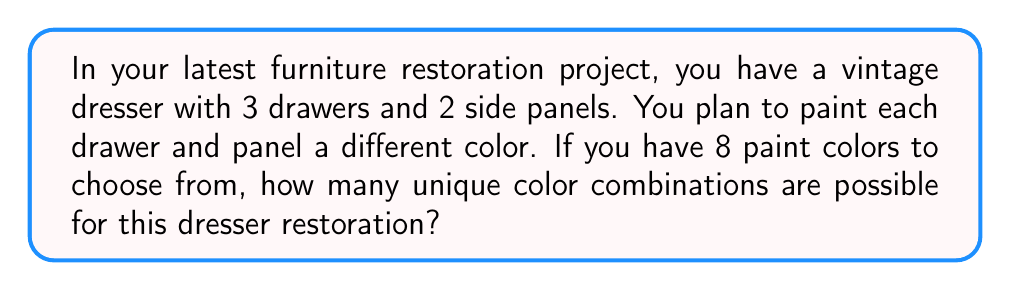Show me your answer to this math problem. Let's approach this step-by-step:

1) We need to choose colors for 5 different parts of the dresser (3 drawers and 2 side panels).

2) For each part, we have 8 color choices.

3) We're selecting colors without replacement, as each part needs to be a different color.

4) This scenario is a perfect application of the permutation formula.

5) The permutation formula is:

   $$P(n,r) = \frac{n!}{(n-r)!}$$

   Where $n$ is the total number of options (in this case, 8 colors), and $r$ is the number of selections we're making (in this case, 5 parts).

6) Plugging in our values:

   $$P(8,5) = \frac{8!}{(8-5)!} = \frac{8!}{3!}$$

7) Let's calculate this:
   
   $$\frac{8 * 7 * 6 * 5 * 4 * 3!}{3!} = 8 * 7 * 6 * 5 * 4 = 6720$$

Therefore, there are 6720 unique color combinations possible for this dresser restoration.
Answer: 6720 